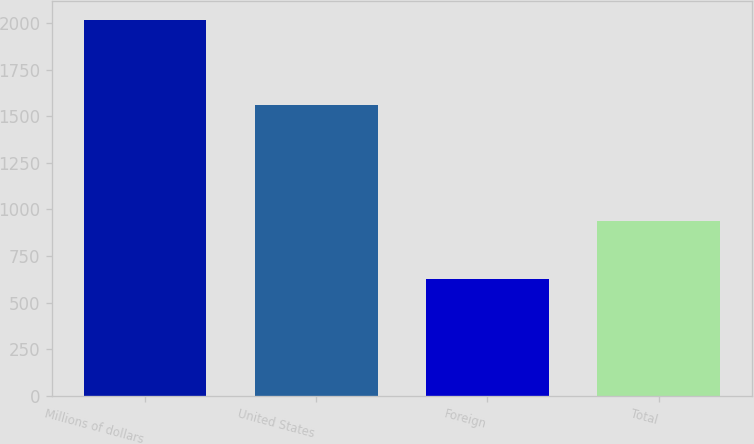<chart> <loc_0><loc_0><loc_500><loc_500><bar_chart><fcel>Millions of dollars<fcel>United States<fcel>Foreign<fcel>Total<nl><fcel>2015<fcel>1560<fcel>624<fcel>936<nl></chart> 